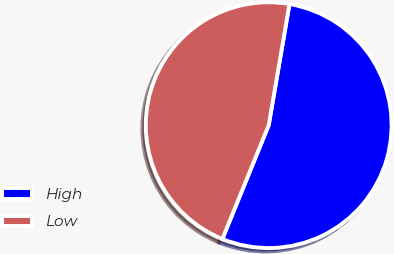Convert chart to OTSL. <chart><loc_0><loc_0><loc_500><loc_500><pie_chart><fcel>High<fcel>Low<nl><fcel>53.45%<fcel>46.55%<nl></chart> 